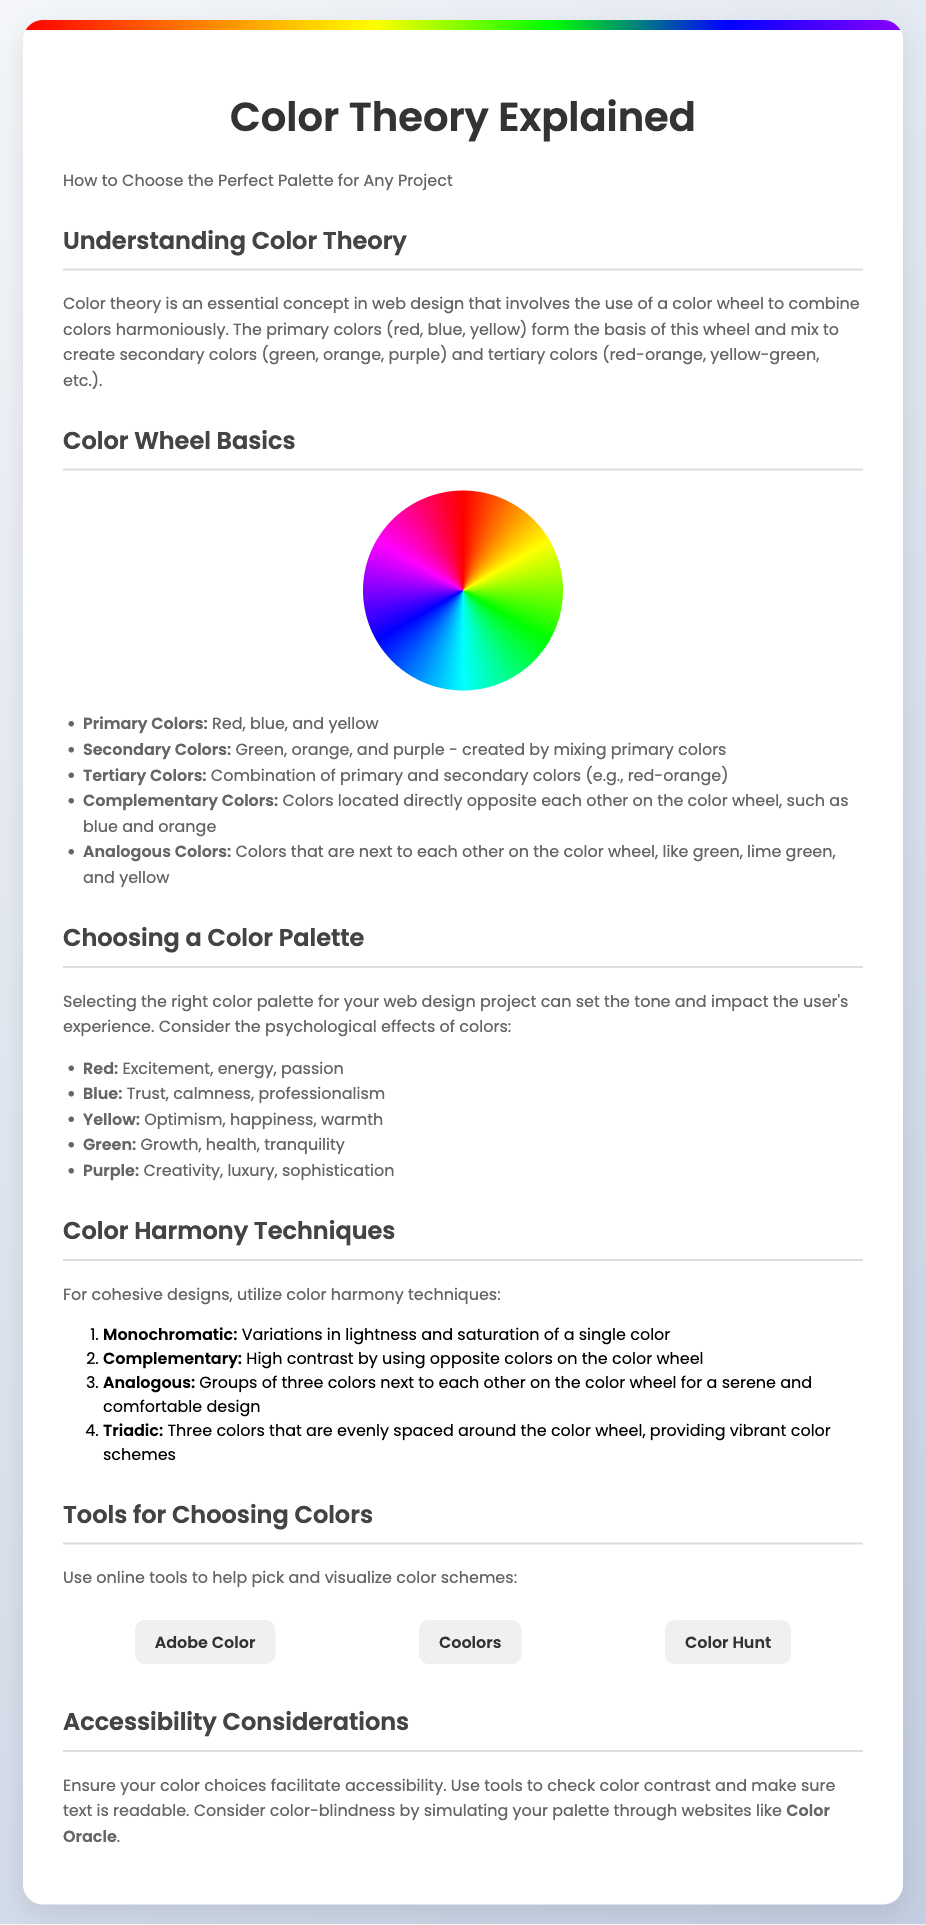what is the title of the flyer? The title of the flyer is presented prominently at the top.
Answer: Color Theory Explained how many primary colors are there? The document mentions primary colors in the color wheel basics section.
Answer: Three what colors are considered primary colors? The primary colors are listed under color wheel basics.
Answer: Red, blue, and yellow name one tool suggested for choosing colors. The tools section lists several tools for color selection.
Answer: Adobe Color what emotional effect does the color red convey? The psychological effects of colors are outlined, including red's impact.
Answer: Excitement what are complementary colors? The definition of complementary colors is explained in the color wheel basics.
Answer: Opposite colors on the color wheel which color harmony technique involves using variations of a single color? The color harmony techniques section describes various methods.
Answer: Monochromatic what is recommended for accessibility in color choices? The accessibility considerations section advises checking color contrast.
Answer: Check color contrast 